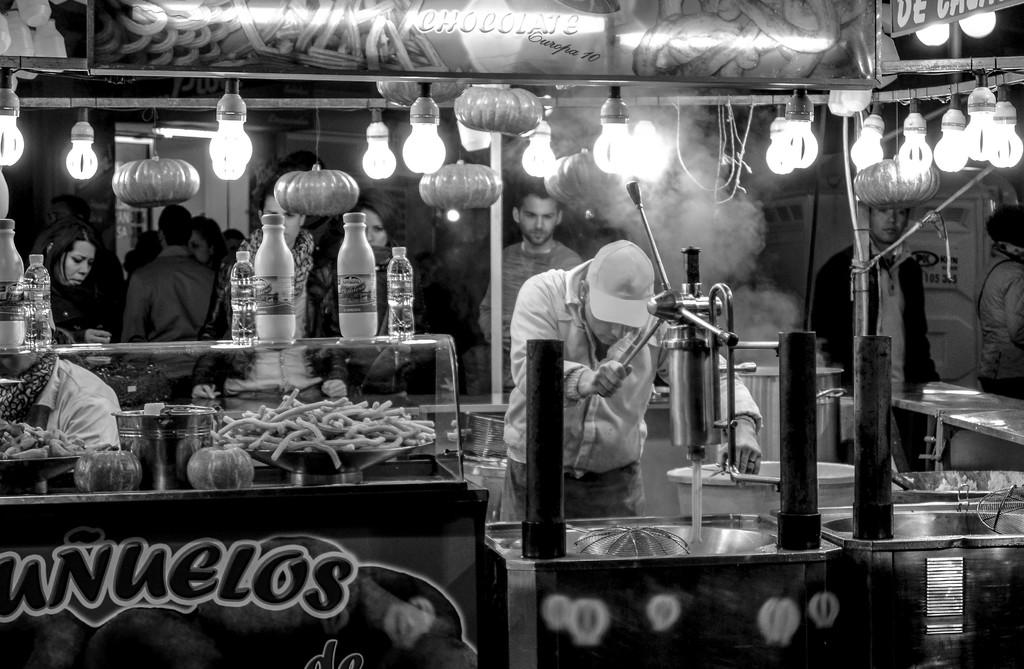What type of location is depicted in the image? The image appears to depict a food court. What is happening in the food court? Food items are being prepared in the image. Are there any people present in the image? Yes, there are groups of people waiting for food in the image. What can be seen in the background of the image? There is a door visible in the background of the image. Who is wearing a crown in the image? There is no one wearing a crown in the image. What type of cloth is being used to prepare the food in the image? The image does not provide information about the specific materials used in food preparation. 